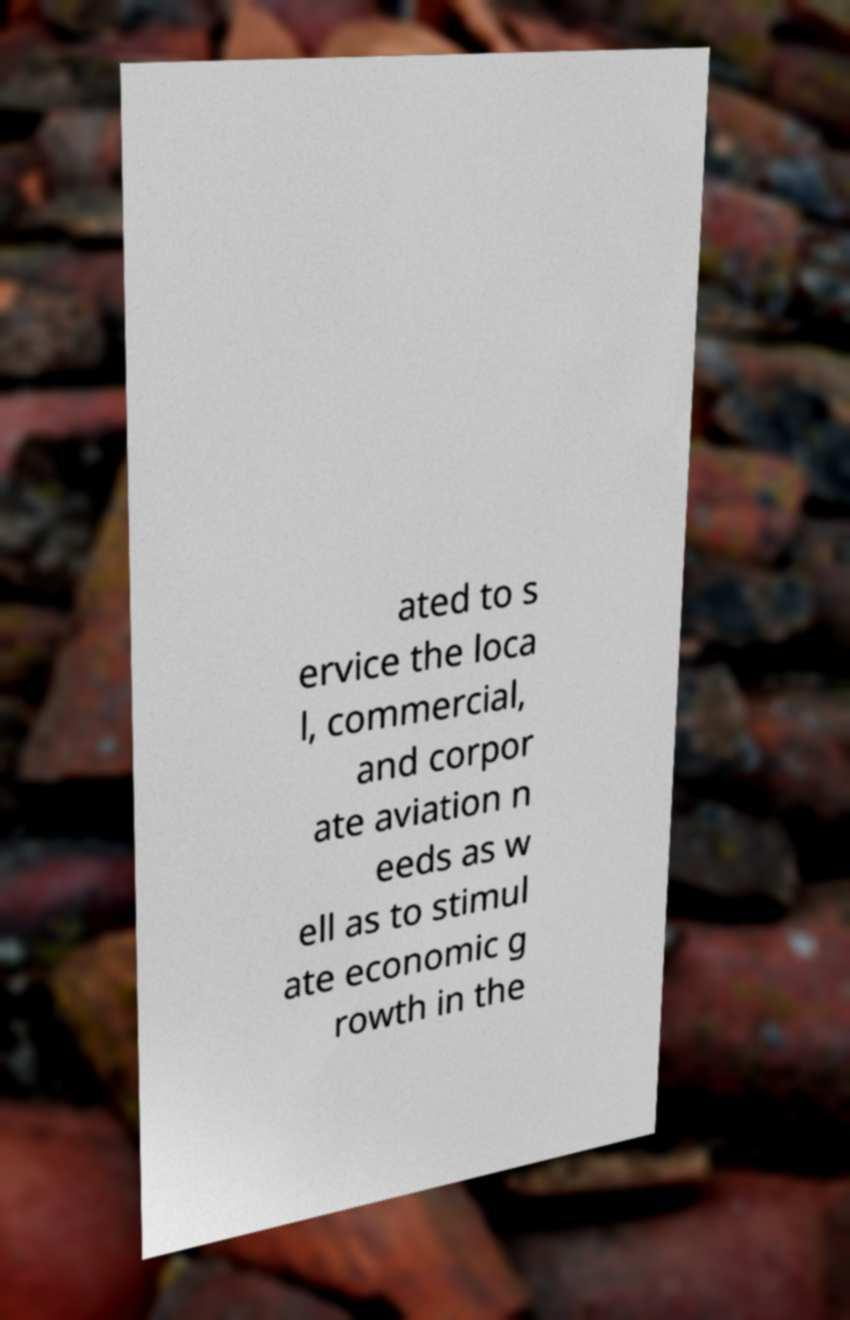I need the written content from this picture converted into text. Can you do that? ated to s ervice the loca l, commercial, and corpor ate aviation n eeds as w ell as to stimul ate economic g rowth in the 